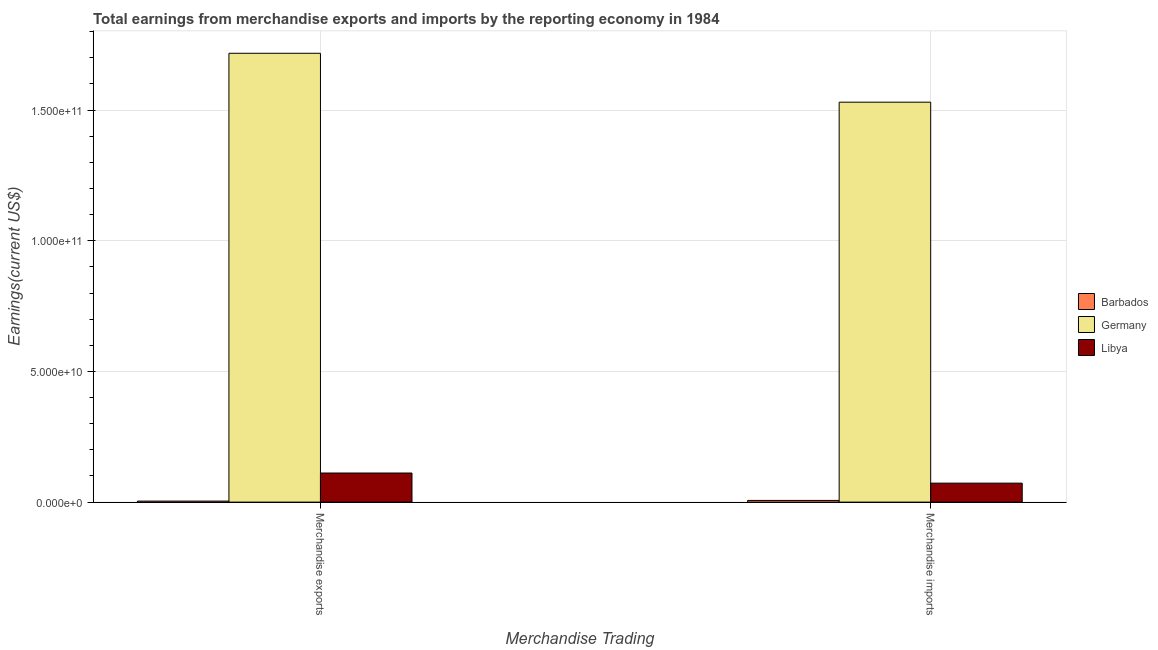How many groups of bars are there?
Offer a very short reply. 2. Are the number of bars on each tick of the X-axis equal?
Give a very brief answer. Yes. How many bars are there on the 2nd tick from the left?
Give a very brief answer. 3. What is the label of the 1st group of bars from the left?
Ensure brevity in your answer.  Merchandise exports. What is the earnings from merchandise imports in Germany?
Provide a succinct answer. 1.53e+11. Across all countries, what is the maximum earnings from merchandise imports?
Make the answer very short. 1.53e+11. Across all countries, what is the minimum earnings from merchandise imports?
Ensure brevity in your answer.  6.57e+08. In which country was the earnings from merchandise exports maximum?
Your answer should be compact. Germany. In which country was the earnings from merchandise imports minimum?
Keep it short and to the point. Barbados. What is the total earnings from merchandise exports in the graph?
Your answer should be very brief. 1.83e+11. What is the difference between the earnings from merchandise imports in Libya and that in Barbados?
Provide a succinct answer. 6.60e+09. What is the difference between the earnings from merchandise imports in Libya and the earnings from merchandise exports in Barbados?
Provide a short and direct response. 6.87e+09. What is the average earnings from merchandise exports per country?
Your answer should be compact. 6.11e+1. What is the difference between the earnings from merchandise imports and earnings from merchandise exports in Libya?
Ensure brevity in your answer.  -3.88e+09. In how many countries, is the earnings from merchandise exports greater than 20000000000 US$?
Give a very brief answer. 1. What is the ratio of the earnings from merchandise exports in Barbados to that in Germany?
Offer a terse response. 0. What does the 1st bar from the left in Merchandise exports represents?
Your response must be concise. Barbados. What does the 1st bar from the right in Merchandise imports represents?
Your answer should be compact. Libya. How many bars are there?
Provide a succinct answer. 6. Are all the bars in the graph horizontal?
Your answer should be compact. No. How many countries are there in the graph?
Your answer should be very brief. 3. Are the values on the major ticks of Y-axis written in scientific E-notation?
Offer a terse response. Yes. How many legend labels are there?
Give a very brief answer. 3. What is the title of the graph?
Your answer should be very brief. Total earnings from merchandise exports and imports by the reporting economy in 1984. What is the label or title of the X-axis?
Give a very brief answer. Merchandise Trading. What is the label or title of the Y-axis?
Make the answer very short. Earnings(current US$). What is the Earnings(current US$) in Barbados in Merchandise exports?
Your answer should be very brief. 3.90e+08. What is the Earnings(current US$) of Germany in Merchandise exports?
Offer a terse response. 1.72e+11. What is the Earnings(current US$) in Libya in Merchandise exports?
Keep it short and to the point. 1.11e+1. What is the Earnings(current US$) in Barbados in Merchandise imports?
Ensure brevity in your answer.  6.57e+08. What is the Earnings(current US$) in Germany in Merchandise imports?
Your answer should be very brief. 1.53e+11. What is the Earnings(current US$) of Libya in Merchandise imports?
Offer a very short reply. 7.26e+09. Across all Merchandise Trading, what is the maximum Earnings(current US$) of Barbados?
Your answer should be very brief. 6.57e+08. Across all Merchandise Trading, what is the maximum Earnings(current US$) in Germany?
Ensure brevity in your answer.  1.72e+11. Across all Merchandise Trading, what is the maximum Earnings(current US$) of Libya?
Offer a very short reply. 1.11e+1. Across all Merchandise Trading, what is the minimum Earnings(current US$) in Barbados?
Keep it short and to the point. 3.90e+08. Across all Merchandise Trading, what is the minimum Earnings(current US$) of Germany?
Your answer should be compact. 1.53e+11. Across all Merchandise Trading, what is the minimum Earnings(current US$) of Libya?
Your answer should be very brief. 7.26e+09. What is the total Earnings(current US$) of Barbados in the graph?
Provide a short and direct response. 1.05e+09. What is the total Earnings(current US$) in Germany in the graph?
Your answer should be compact. 3.25e+11. What is the total Earnings(current US$) of Libya in the graph?
Provide a succinct answer. 1.84e+1. What is the difference between the Earnings(current US$) of Barbados in Merchandise exports and that in Merchandise imports?
Your response must be concise. -2.67e+08. What is the difference between the Earnings(current US$) of Germany in Merchandise exports and that in Merchandise imports?
Provide a succinct answer. 1.87e+1. What is the difference between the Earnings(current US$) in Libya in Merchandise exports and that in Merchandise imports?
Make the answer very short. 3.88e+09. What is the difference between the Earnings(current US$) of Barbados in Merchandise exports and the Earnings(current US$) of Germany in Merchandise imports?
Provide a short and direct response. -1.53e+11. What is the difference between the Earnings(current US$) of Barbados in Merchandise exports and the Earnings(current US$) of Libya in Merchandise imports?
Keep it short and to the point. -6.87e+09. What is the difference between the Earnings(current US$) of Germany in Merchandise exports and the Earnings(current US$) of Libya in Merchandise imports?
Ensure brevity in your answer.  1.64e+11. What is the average Earnings(current US$) in Barbados per Merchandise Trading?
Offer a very short reply. 5.23e+08. What is the average Earnings(current US$) of Germany per Merchandise Trading?
Offer a terse response. 1.62e+11. What is the average Earnings(current US$) of Libya per Merchandise Trading?
Keep it short and to the point. 9.20e+09. What is the difference between the Earnings(current US$) in Barbados and Earnings(current US$) in Germany in Merchandise exports?
Give a very brief answer. -1.71e+11. What is the difference between the Earnings(current US$) of Barbados and Earnings(current US$) of Libya in Merchandise exports?
Offer a very short reply. -1.07e+1. What is the difference between the Earnings(current US$) of Germany and Earnings(current US$) of Libya in Merchandise exports?
Your answer should be very brief. 1.61e+11. What is the difference between the Earnings(current US$) in Barbados and Earnings(current US$) in Germany in Merchandise imports?
Offer a very short reply. -1.52e+11. What is the difference between the Earnings(current US$) in Barbados and Earnings(current US$) in Libya in Merchandise imports?
Make the answer very short. -6.60e+09. What is the difference between the Earnings(current US$) in Germany and Earnings(current US$) in Libya in Merchandise imports?
Provide a succinct answer. 1.46e+11. What is the ratio of the Earnings(current US$) in Barbados in Merchandise exports to that in Merchandise imports?
Keep it short and to the point. 0.59. What is the ratio of the Earnings(current US$) in Germany in Merchandise exports to that in Merchandise imports?
Provide a succinct answer. 1.12. What is the ratio of the Earnings(current US$) of Libya in Merchandise exports to that in Merchandise imports?
Offer a terse response. 1.53. What is the difference between the highest and the second highest Earnings(current US$) in Barbados?
Provide a short and direct response. 2.67e+08. What is the difference between the highest and the second highest Earnings(current US$) in Germany?
Give a very brief answer. 1.87e+1. What is the difference between the highest and the second highest Earnings(current US$) of Libya?
Your response must be concise. 3.88e+09. What is the difference between the highest and the lowest Earnings(current US$) in Barbados?
Ensure brevity in your answer.  2.67e+08. What is the difference between the highest and the lowest Earnings(current US$) of Germany?
Keep it short and to the point. 1.87e+1. What is the difference between the highest and the lowest Earnings(current US$) in Libya?
Offer a terse response. 3.88e+09. 